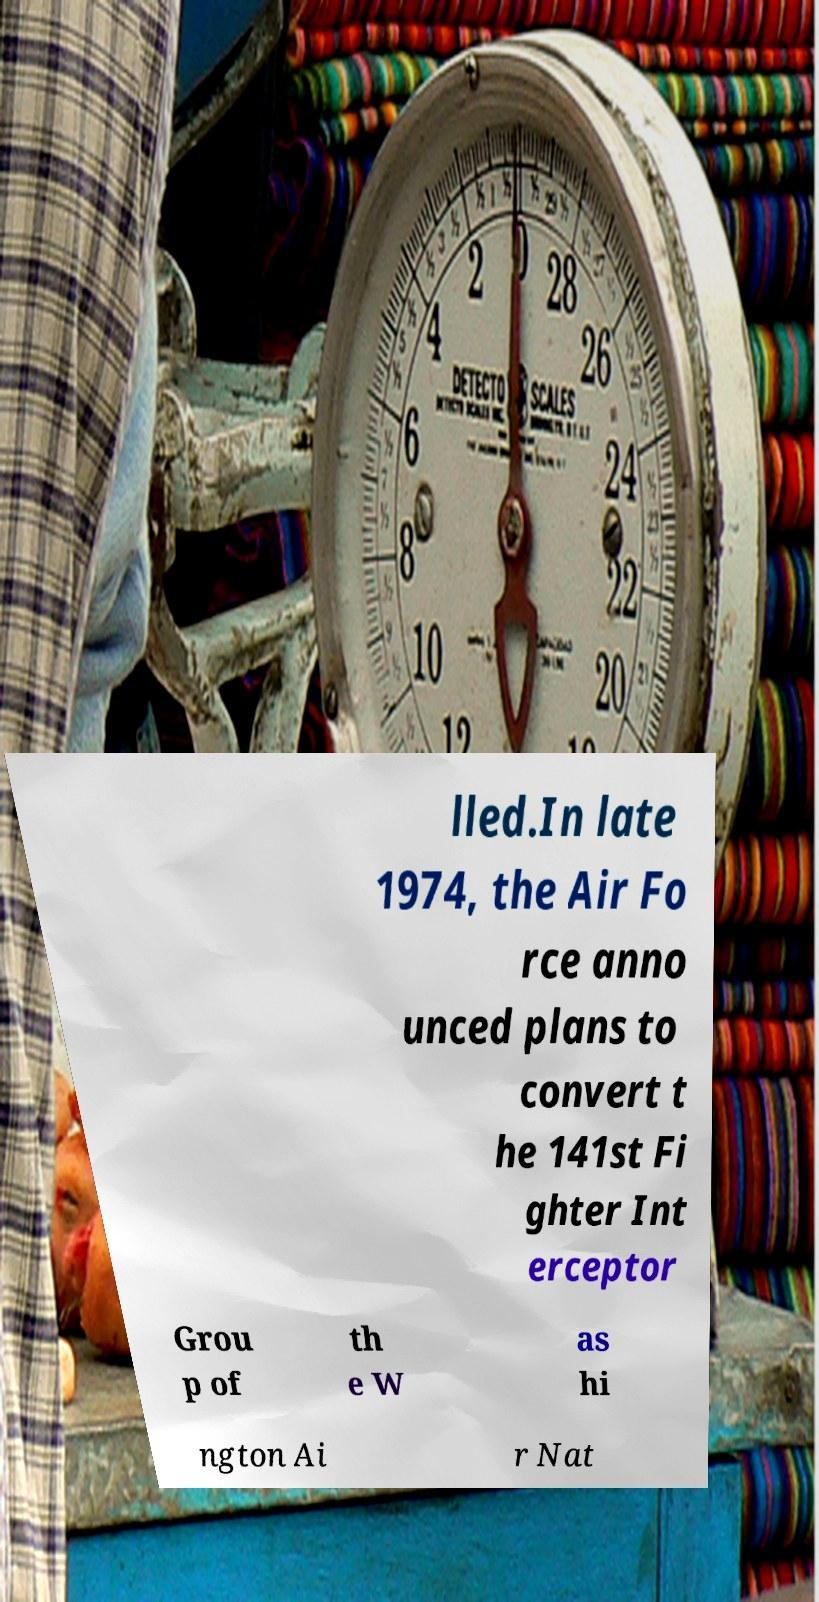Could you extract and type out the text from this image? lled.In late 1974, the Air Fo rce anno unced plans to convert t he 141st Fi ghter Int erceptor Grou p of th e W as hi ngton Ai r Nat 